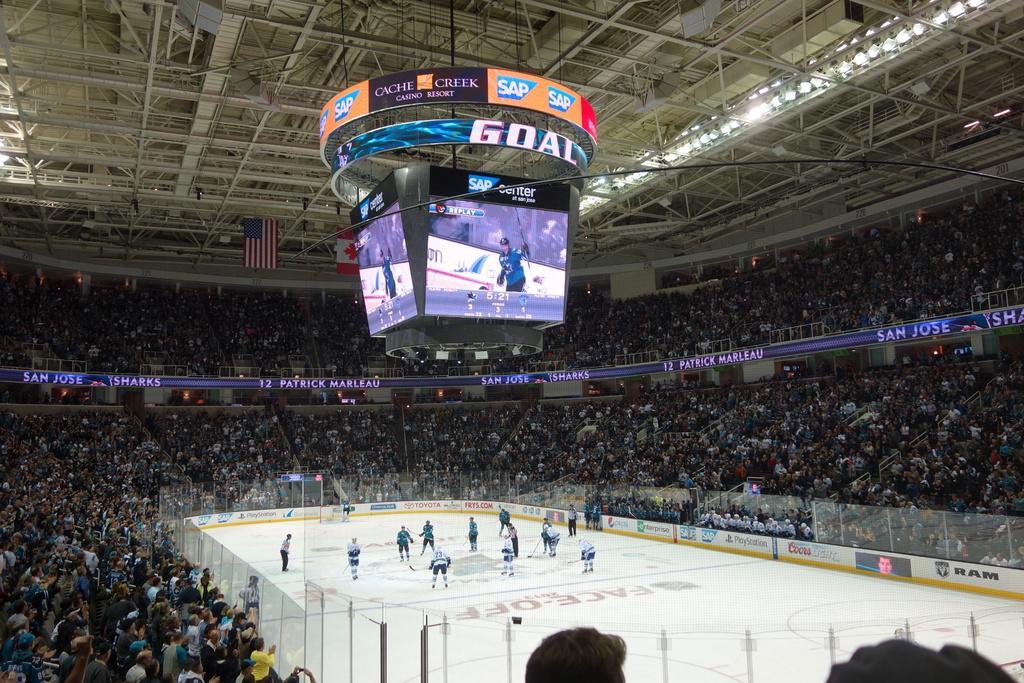How would you summarize this image in a sentence or two? In this image, I can see a group of people playing the ice hockey game. I think this picture was taken in the stadium. It looks like a scoreboard and a hoarding, which are hanging to the ceiling. There are groups of people in the stadium. These look like the glass doors. In the background, I can see the flags hanging to the ceiling. 